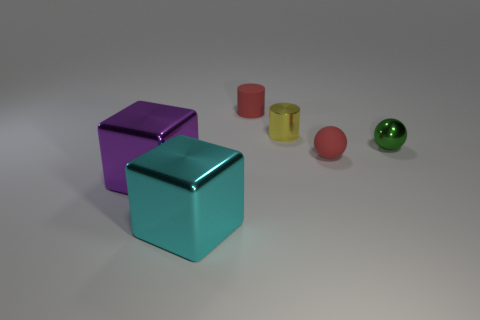Add 3 big green metal objects. How many objects exist? 9 Subtract all cylinders. How many objects are left? 4 Subtract 0 gray balls. How many objects are left? 6 Subtract all large cyan metal things. Subtract all brown things. How many objects are left? 5 Add 6 tiny green metallic objects. How many tiny green metallic objects are left? 7 Add 1 yellow metallic cylinders. How many yellow metallic cylinders exist? 2 